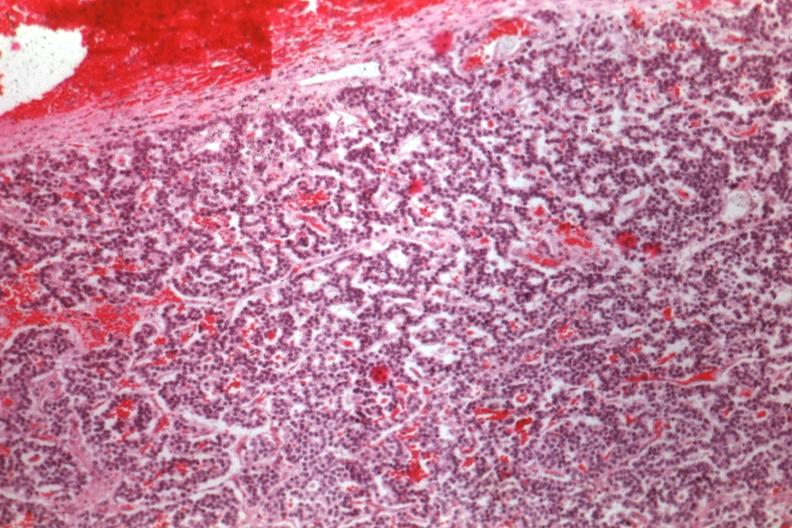s 70yof present?
Answer the question using a single word or phrase. No 